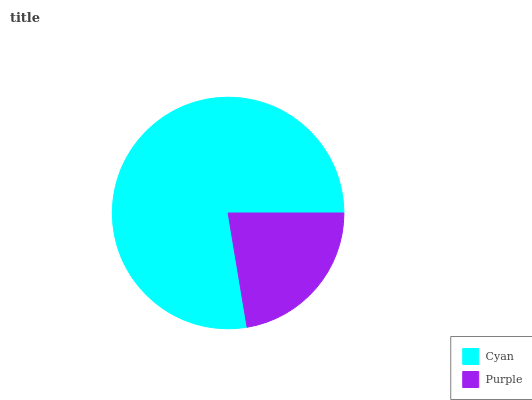Is Purple the minimum?
Answer yes or no. Yes. Is Cyan the maximum?
Answer yes or no. Yes. Is Purple the maximum?
Answer yes or no. No. Is Cyan greater than Purple?
Answer yes or no. Yes. Is Purple less than Cyan?
Answer yes or no. Yes. Is Purple greater than Cyan?
Answer yes or no. No. Is Cyan less than Purple?
Answer yes or no. No. Is Cyan the high median?
Answer yes or no. Yes. Is Purple the low median?
Answer yes or no. Yes. Is Purple the high median?
Answer yes or no. No. Is Cyan the low median?
Answer yes or no. No. 